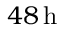<formula> <loc_0><loc_0><loc_500><loc_500>4 8 \, h</formula> 